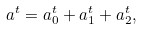Convert formula to latex. <formula><loc_0><loc_0><loc_500><loc_500>a ^ { t } = a _ { 0 } ^ { t } + a _ { 1 } ^ { t } + a _ { 2 } ^ { t } ,</formula> 